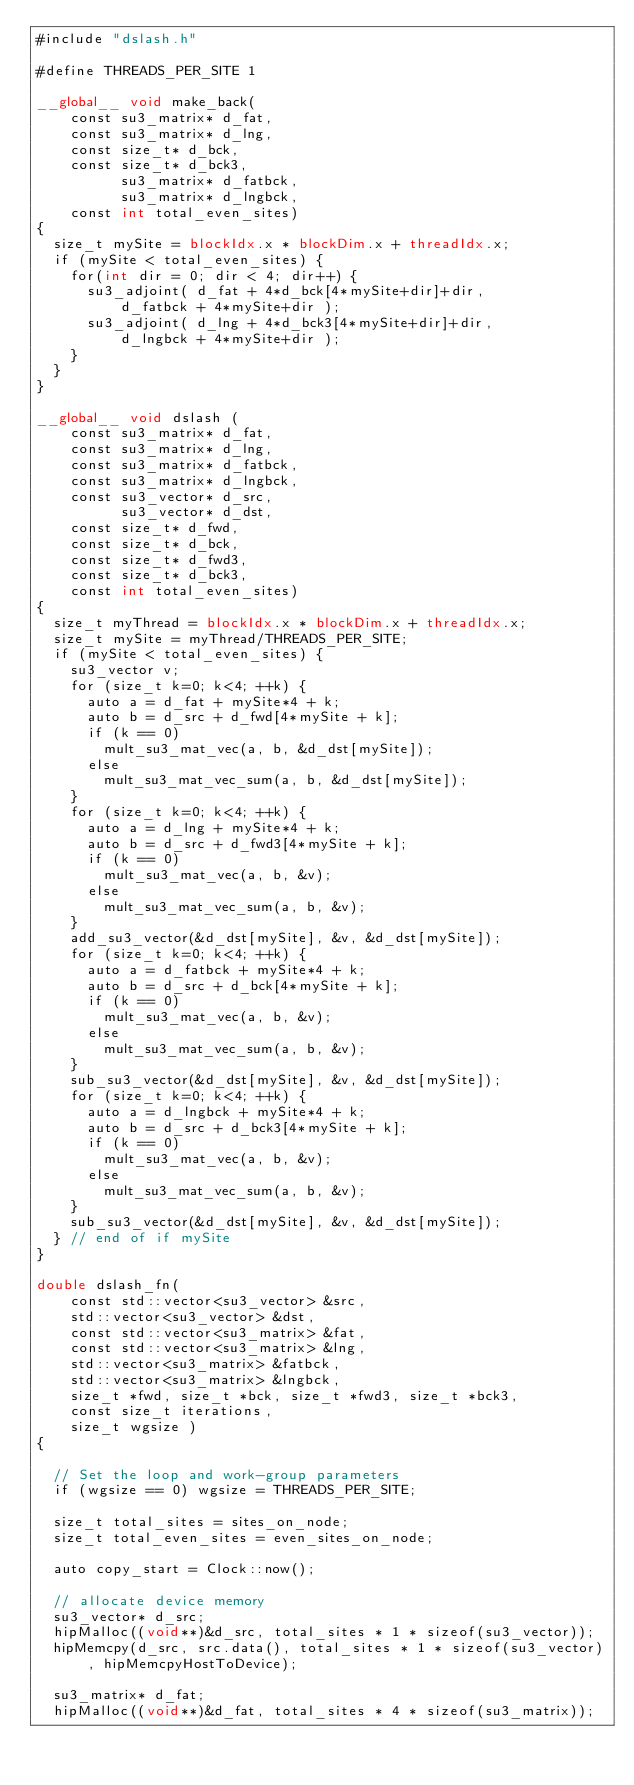Convert code to text. <code><loc_0><loc_0><loc_500><loc_500><_Cuda_>#include "dslash.h"

#define THREADS_PER_SITE 1

__global__ void make_back(
    const su3_matrix* d_fat,
    const su3_matrix* d_lng,
    const size_t* d_bck, 
    const size_t* d_bck3,
          su3_matrix* d_fatbck,
          su3_matrix* d_lngbck,
    const int total_even_sites)
{
  size_t mySite = blockIdx.x * blockDim.x + threadIdx.x;
  if (mySite < total_even_sites) {
    for(int dir = 0; dir < 4; dir++) {
      su3_adjoint( d_fat + 4*d_bck[4*mySite+dir]+dir, 
          d_fatbck + 4*mySite+dir );
      su3_adjoint( d_lng + 4*d_bck3[4*mySite+dir]+dir, 
          d_lngbck + 4*mySite+dir );
    }
  }
}

__global__ void dslash (
    const su3_matrix* d_fat,
    const su3_matrix* d_lng,
    const su3_matrix* d_fatbck,
    const su3_matrix* d_lngbck,
    const su3_vector* d_src,
          su3_vector* d_dst,
    const size_t* d_fwd,
    const size_t* d_bck,
    const size_t* d_fwd3,
    const size_t* d_bck3,
    const int total_even_sites)
{
  size_t myThread = blockIdx.x * blockDim.x + threadIdx.x;
  size_t mySite = myThread/THREADS_PER_SITE;
  if (mySite < total_even_sites) {
    su3_vector v;
    for (size_t k=0; k<4; ++k) {
      auto a = d_fat + mySite*4 + k;
      auto b = d_src + d_fwd[4*mySite + k];
      if (k == 0)
        mult_su3_mat_vec(a, b, &d_dst[mySite]);
      else 
        mult_su3_mat_vec_sum(a, b, &d_dst[mySite]);
    }
    for (size_t k=0; k<4; ++k) {
      auto a = d_lng + mySite*4 + k;
      auto b = d_src + d_fwd3[4*mySite + k];
      if (k == 0) 
        mult_su3_mat_vec(a, b, &v);
      else
        mult_su3_mat_vec_sum(a, b, &v);
    }
    add_su3_vector(&d_dst[mySite], &v, &d_dst[mySite]);
    for (size_t k=0; k<4; ++k) {
      auto a = d_fatbck + mySite*4 + k;
      auto b = d_src + d_bck[4*mySite + k];
      if (k == 0) 
        mult_su3_mat_vec(a, b, &v);
      else
        mult_su3_mat_vec_sum(a, b, &v);
    }
    sub_su3_vector(&d_dst[mySite], &v, &d_dst[mySite]);
    for (size_t k=0; k<4; ++k) {
      auto a = d_lngbck + mySite*4 + k;
      auto b = d_src + d_bck3[4*mySite + k];
      if (k == 0) 
        mult_su3_mat_vec(a, b, &v);
      else
        mult_su3_mat_vec_sum(a, b, &v);
    }
    sub_su3_vector(&d_dst[mySite], &v, &d_dst[mySite]);
  } // end of if mySite
}

double dslash_fn(
    const std::vector<su3_vector> &src, 
    std::vector<su3_vector> &dst,
    const std::vector<su3_matrix> &fat,
    const std::vector<su3_matrix> &lng,
    std::vector<su3_matrix> &fatbck,
    std::vector<su3_matrix> &lngbck,
    size_t *fwd, size_t *bck, size_t *fwd3, size_t *bck3,    
    const size_t iterations,
    size_t wgsize )
{ 

  // Set the loop and work-group parameters
  if (wgsize == 0) wgsize = THREADS_PER_SITE;

  size_t total_sites = sites_on_node; 
  size_t total_even_sites = even_sites_on_node;

  auto copy_start = Clock::now();

  // allocate device memory
  su3_vector* d_src;
  hipMalloc((void**)&d_src, total_sites * 1 * sizeof(su3_vector));
  hipMemcpy(d_src, src.data(), total_sites * 1 * sizeof(su3_vector), hipMemcpyHostToDevice);

  su3_matrix* d_fat;
  hipMalloc((void**)&d_fat, total_sites * 4 * sizeof(su3_matrix));</code> 